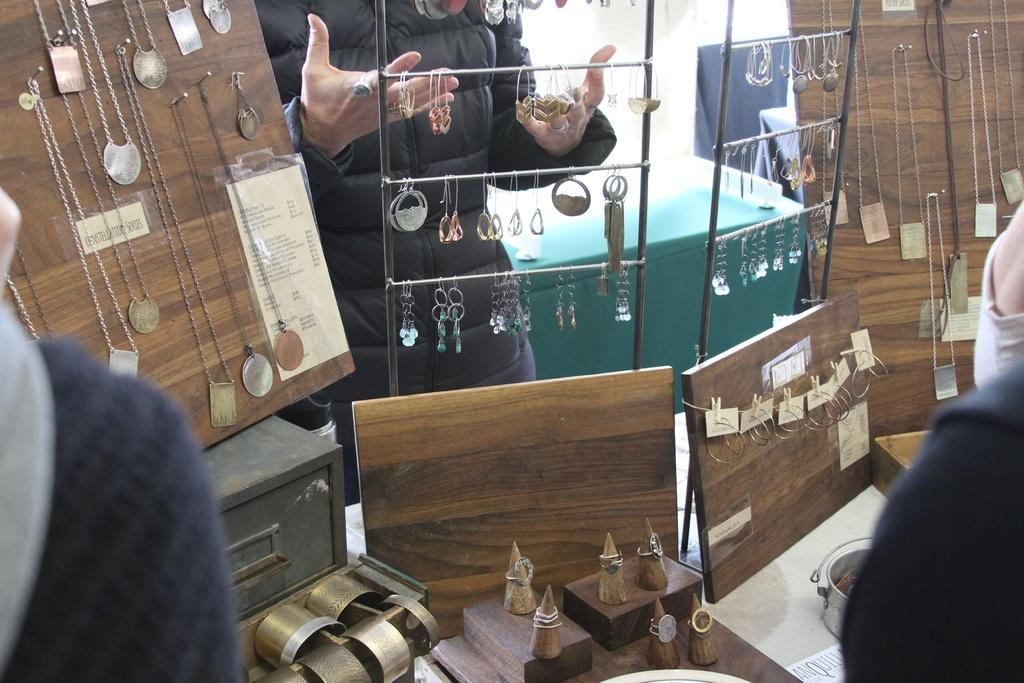What is the man in the image doing? The man is standing in the image and holding earrings in his hands. What other items related to jewelry can be seen in the image? There are chains on a board, bangles, and additional earrings in the image. How many other people are present in the image? There are two other persons in the image. Is the man in the image sleeping while holding the earrings? No, the man is not sleeping in the image; he is standing and holding earrings in his hands. 